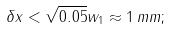Convert formula to latex. <formula><loc_0><loc_0><loc_500><loc_500>\delta x < \sqrt { 0 . 0 5 } w _ { 1 } \approx 1 \, m m ;</formula> 